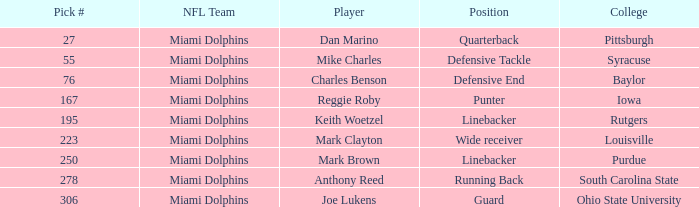Parse the table in full. {'header': ['Pick #', 'NFL Team', 'Player', 'Position', 'College'], 'rows': [['27', 'Miami Dolphins', 'Dan Marino', 'Quarterback', 'Pittsburgh'], ['55', 'Miami Dolphins', 'Mike Charles', 'Defensive Tackle', 'Syracuse'], ['76', 'Miami Dolphins', 'Charles Benson', 'Defensive End', 'Baylor'], ['167', 'Miami Dolphins', 'Reggie Roby', 'Punter', 'Iowa'], ['195', 'Miami Dolphins', 'Keith Woetzel', 'Linebacker', 'Rutgers'], ['223', 'Miami Dolphins', 'Mark Clayton', 'Wide receiver', 'Louisville'], ['250', 'Miami Dolphins', 'Mark Brown', 'Linebacker', 'Purdue'], ['278', 'Miami Dolphins', 'Anthony Reed', 'Running Back', 'South Carolina State'], ['306', 'Miami Dolphins', 'Joe Lukens', 'Guard', 'Ohio State University']]} For charles benson, which placement has a pick numeral lesser than 278? Defensive End. 